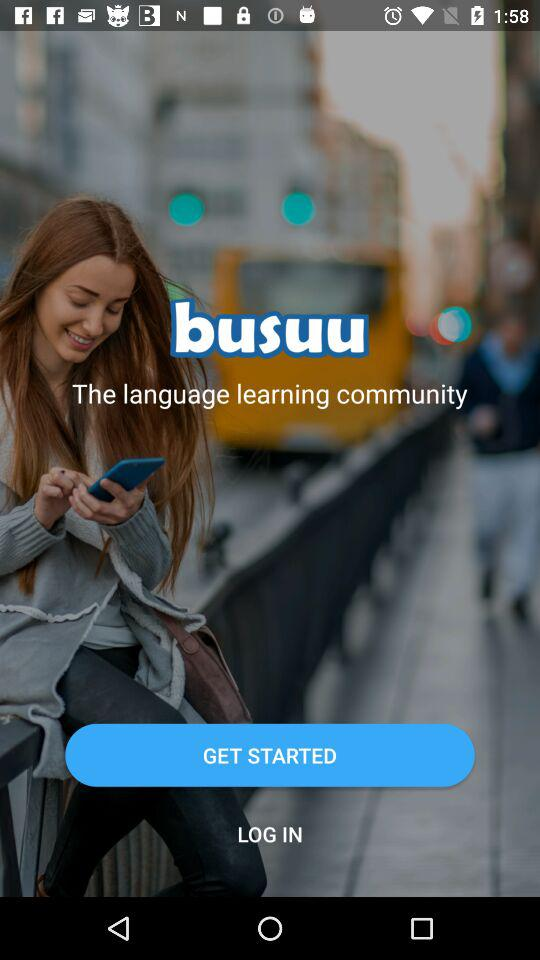What is the name of the application? The name of the application is "busuu". 